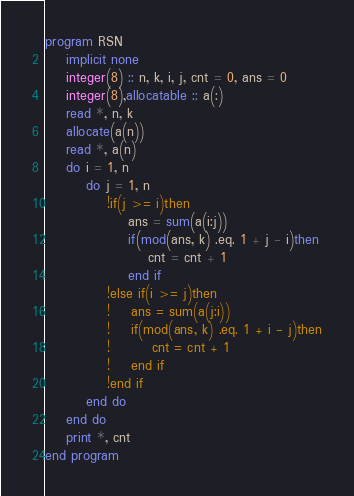Convert code to text. <code><loc_0><loc_0><loc_500><loc_500><_FORTRAN_>program RSN
    implicit none
    integer(8) :: n, k, i, j, cnt = 0, ans = 0
    integer(8),allocatable :: a(:)
    read *, n, k
    allocate(a(n))
    read *, a(n)
    do i = 1, n
        do j = 1, n
            !if(j >= i)then
                ans = sum(a(i:j))
                if(mod(ans, k) .eq. 1 + j - i)then
                    cnt = cnt + 1
                end if
            !else if(i >= j)then
            !    ans = sum(a(j:i))
            !    if(mod(ans, k) .eq. 1 + i - j)then
            !        cnt = cnt + 1
            !    end if
            !end if
        end do
    end do
    print *, cnt
end program</code> 